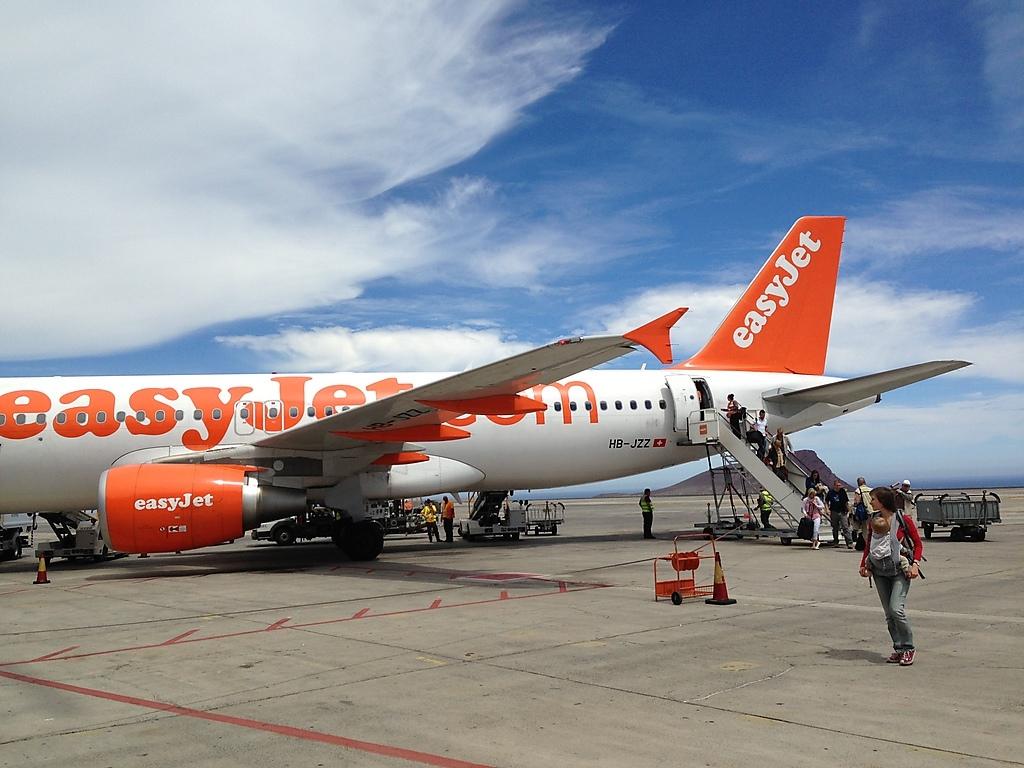What is the identification number by the flag decal on the plane?
Keep it short and to the point. Hb-jzz. 